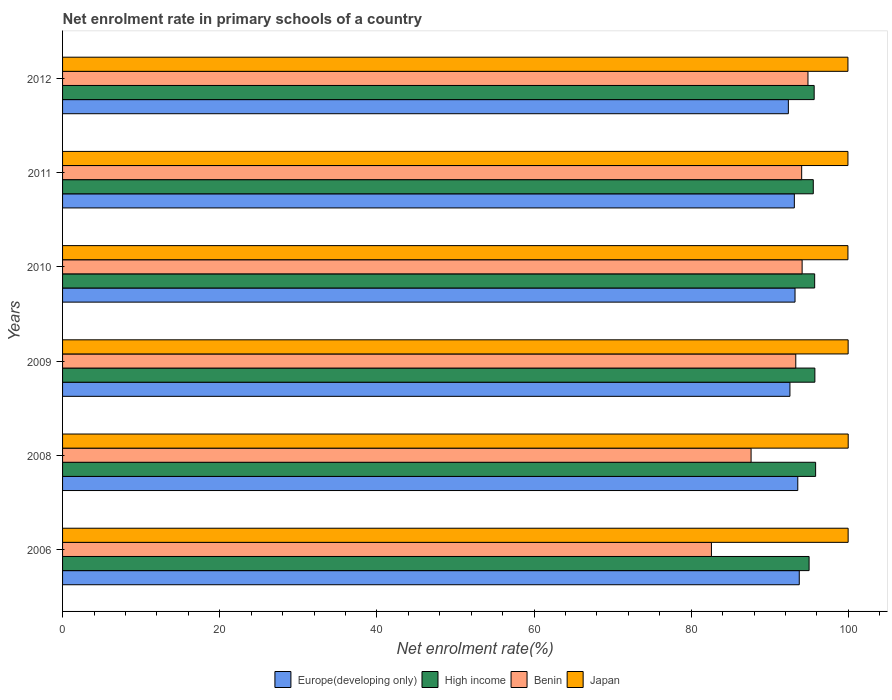How many groups of bars are there?
Your response must be concise. 6. Are the number of bars per tick equal to the number of legend labels?
Keep it short and to the point. Yes. Are the number of bars on each tick of the Y-axis equal?
Provide a short and direct response. Yes. What is the net enrolment rate in primary schools in Japan in 2011?
Keep it short and to the point. 99.95. Across all years, what is the maximum net enrolment rate in primary schools in High income?
Your answer should be compact. 95.84. Across all years, what is the minimum net enrolment rate in primary schools in Benin?
Provide a short and direct response. 82.58. What is the total net enrolment rate in primary schools in High income in the graph?
Provide a succinct answer. 573.5. What is the difference between the net enrolment rate in primary schools in Japan in 2008 and that in 2011?
Your response must be concise. 0.04. What is the difference between the net enrolment rate in primary schools in High income in 2006 and the net enrolment rate in primary schools in Japan in 2009?
Provide a short and direct response. -4.97. What is the average net enrolment rate in primary schools in Benin per year?
Give a very brief answer. 91.09. In the year 2006, what is the difference between the net enrolment rate in primary schools in Europe(developing only) and net enrolment rate in primary schools in High income?
Your answer should be compact. -1.25. In how many years, is the net enrolment rate in primary schools in Benin greater than 36 %?
Your answer should be compact. 6. What is the ratio of the net enrolment rate in primary schools in Europe(developing only) in 2008 to that in 2011?
Your answer should be very brief. 1. What is the difference between the highest and the second highest net enrolment rate in primary schools in Europe(developing only)?
Provide a succinct answer. 0.19. What is the difference between the highest and the lowest net enrolment rate in primary schools in High income?
Provide a short and direct response. 0.83. Is the sum of the net enrolment rate in primary schools in High income in 2010 and 2012 greater than the maximum net enrolment rate in primary schools in Europe(developing only) across all years?
Your answer should be very brief. Yes. Is it the case that in every year, the sum of the net enrolment rate in primary schools in Japan and net enrolment rate in primary schools in High income is greater than the sum of net enrolment rate in primary schools in Europe(developing only) and net enrolment rate in primary schools in Benin?
Your answer should be compact. Yes. What does the 2nd bar from the top in 2008 represents?
Offer a terse response. Benin. What does the 2nd bar from the bottom in 2010 represents?
Provide a short and direct response. High income. Is it the case that in every year, the sum of the net enrolment rate in primary schools in Benin and net enrolment rate in primary schools in Japan is greater than the net enrolment rate in primary schools in Europe(developing only)?
Make the answer very short. Yes. Are all the bars in the graph horizontal?
Your response must be concise. Yes. Are the values on the major ticks of X-axis written in scientific E-notation?
Give a very brief answer. No. Does the graph contain any zero values?
Make the answer very short. No. Where does the legend appear in the graph?
Make the answer very short. Bottom center. How are the legend labels stacked?
Give a very brief answer. Horizontal. What is the title of the graph?
Offer a very short reply. Net enrolment rate in primary schools of a country. Does "Latin America(developing only)" appear as one of the legend labels in the graph?
Your answer should be very brief. No. What is the label or title of the X-axis?
Offer a terse response. Net enrolment rate(%). What is the Net enrolment rate(%) in Europe(developing only) in 2006?
Keep it short and to the point. 93.76. What is the Net enrolment rate(%) of High income in 2006?
Provide a succinct answer. 95.01. What is the Net enrolment rate(%) in Benin in 2006?
Your answer should be very brief. 82.58. What is the Net enrolment rate(%) of Japan in 2006?
Offer a terse response. 99.98. What is the Net enrolment rate(%) in Europe(developing only) in 2008?
Offer a very short reply. 93.57. What is the Net enrolment rate(%) of High income in 2008?
Provide a short and direct response. 95.84. What is the Net enrolment rate(%) of Benin in 2008?
Make the answer very short. 87.62. What is the Net enrolment rate(%) in Japan in 2008?
Keep it short and to the point. 99.99. What is the Net enrolment rate(%) in Europe(developing only) in 2009?
Offer a very short reply. 92.57. What is the Net enrolment rate(%) in High income in 2009?
Your answer should be compact. 95.74. What is the Net enrolment rate(%) in Benin in 2009?
Your answer should be very brief. 93.31. What is the Net enrolment rate(%) in Japan in 2009?
Offer a terse response. 99.98. What is the Net enrolment rate(%) of Europe(developing only) in 2010?
Your answer should be very brief. 93.22. What is the Net enrolment rate(%) in High income in 2010?
Your answer should be compact. 95.72. What is the Net enrolment rate(%) in Benin in 2010?
Your response must be concise. 94.12. What is the Net enrolment rate(%) of Japan in 2010?
Offer a very short reply. 99.95. What is the Net enrolment rate(%) of Europe(developing only) in 2011?
Provide a succinct answer. 93.13. What is the Net enrolment rate(%) of High income in 2011?
Ensure brevity in your answer.  95.54. What is the Net enrolment rate(%) of Benin in 2011?
Offer a terse response. 94.06. What is the Net enrolment rate(%) of Japan in 2011?
Offer a terse response. 99.95. What is the Net enrolment rate(%) of Europe(developing only) in 2012?
Offer a terse response. 92.37. What is the Net enrolment rate(%) of High income in 2012?
Make the answer very short. 95.65. What is the Net enrolment rate(%) of Benin in 2012?
Offer a very short reply. 94.86. What is the Net enrolment rate(%) of Japan in 2012?
Provide a short and direct response. 99.95. Across all years, what is the maximum Net enrolment rate(%) in Europe(developing only)?
Ensure brevity in your answer.  93.76. Across all years, what is the maximum Net enrolment rate(%) of High income?
Your response must be concise. 95.84. Across all years, what is the maximum Net enrolment rate(%) of Benin?
Your answer should be compact. 94.86. Across all years, what is the maximum Net enrolment rate(%) of Japan?
Provide a short and direct response. 99.99. Across all years, what is the minimum Net enrolment rate(%) in Europe(developing only)?
Offer a terse response. 92.37. Across all years, what is the minimum Net enrolment rate(%) of High income?
Offer a terse response. 95.01. Across all years, what is the minimum Net enrolment rate(%) in Benin?
Provide a short and direct response. 82.58. Across all years, what is the minimum Net enrolment rate(%) in Japan?
Your answer should be very brief. 99.95. What is the total Net enrolment rate(%) in Europe(developing only) in the graph?
Offer a very short reply. 558.61. What is the total Net enrolment rate(%) of High income in the graph?
Offer a terse response. 573.5. What is the total Net enrolment rate(%) in Benin in the graph?
Give a very brief answer. 546.56. What is the total Net enrolment rate(%) of Japan in the graph?
Your response must be concise. 599.79. What is the difference between the Net enrolment rate(%) in Europe(developing only) in 2006 and that in 2008?
Your answer should be very brief. 0.19. What is the difference between the Net enrolment rate(%) in High income in 2006 and that in 2008?
Offer a very short reply. -0.83. What is the difference between the Net enrolment rate(%) of Benin in 2006 and that in 2008?
Provide a short and direct response. -5.04. What is the difference between the Net enrolment rate(%) in Japan in 2006 and that in 2008?
Make the answer very short. -0.01. What is the difference between the Net enrolment rate(%) of Europe(developing only) in 2006 and that in 2009?
Offer a terse response. 1.19. What is the difference between the Net enrolment rate(%) of High income in 2006 and that in 2009?
Ensure brevity in your answer.  -0.73. What is the difference between the Net enrolment rate(%) in Benin in 2006 and that in 2009?
Make the answer very short. -10.73. What is the difference between the Net enrolment rate(%) of Japan in 2006 and that in 2009?
Make the answer very short. -0. What is the difference between the Net enrolment rate(%) in Europe(developing only) in 2006 and that in 2010?
Ensure brevity in your answer.  0.54. What is the difference between the Net enrolment rate(%) in High income in 2006 and that in 2010?
Ensure brevity in your answer.  -0.71. What is the difference between the Net enrolment rate(%) in Benin in 2006 and that in 2010?
Ensure brevity in your answer.  -11.54. What is the difference between the Net enrolment rate(%) of Japan in 2006 and that in 2010?
Make the answer very short. 0.03. What is the difference between the Net enrolment rate(%) of Europe(developing only) in 2006 and that in 2011?
Your answer should be very brief. 0.63. What is the difference between the Net enrolment rate(%) of High income in 2006 and that in 2011?
Your answer should be very brief. -0.53. What is the difference between the Net enrolment rate(%) of Benin in 2006 and that in 2011?
Provide a short and direct response. -11.48. What is the difference between the Net enrolment rate(%) in Japan in 2006 and that in 2011?
Offer a terse response. 0.03. What is the difference between the Net enrolment rate(%) in Europe(developing only) in 2006 and that in 2012?
Your answer should be very brief. 1.39. What is the difference between the Net enrolment rate(%) of High income in 2006 and that in 2012?
Keep it short and to the point. -0.65. What is the difference between the Net enrolment rate(%) of Benin in 2006 and that in 2012?
Offer a terse response. -12.28. What is the difference between the Net enrolment rate(%) of Japan in 2006 and that in 2012?
Provide a short and direct response. 0.03. What is the difference between the Net enrolment rate(%) in High income in 2008 and that in 2009?
Your answer should be compact. 0.1. What is the difference between the Net enrolment rate(%) of Benin in 2008 and that in 2009?
Provide a succinct answer. -5.69. What is the difference between the Net enrolment rate(%) of Japan in 2008 and that in 2009?
Offer a very short reply. 0.01. What is the difference between the Net enrolment rate(%) of Europe(developing only) in 2008 and that in 2010?
Offer a very short reply. 0.35. What is the difference between the Net enrolment rate(%) of High income in 2008 and that in 2010?
Ensure brevity in your answer.  0.12. What is the difference between the Net enrolment rate(%) of Benin in 2008 and that in 2010?
Give a very brief answer. -6.5. What is the difference between the Net enrolment rate(%) of Japan in 2008 and that in 2010?
Give a very brief answer. 0.04. What is the difference between the Net enrolment rate(%) in Europe(developing only) in 2008 and that in 2011?
Provide a succinct answer. 0.44. What is the difference between the Net enrolment rate(%) of High income in 2008 and that in 2011?
Give a very brief answer. 0.3. What is the difference between the Net enrolment rate(%) of Benin in 2008 and that in 2011?
Offer a very short reply. -6.44. What is the difference between the Net enrolment rate(%) of Japan in 2008 and that in 2011?
Your response must be concise. 0.04. What is the difference between the Net enrolment rate(%) in Europe(developing only) in 2008 and that in 2012?
Make the answer very short. 1.2. What is the difference between the Net enrolment rate(%) of High income in 2008 and that in 2012?
Offer a terse response. 0.19. What is the difference between the Net enrolment rate(%) of Benin in 2008 and that in 2012?
Offer a very short reply. -7.24. What is the difference between the Net enrolment rate(%) in Japan in 2008 and that in 2012?
Your answer should be compact. 0.04. What is the difference between the Net enrolment rate(%) in Europe(developing only) in 2009 and that in 2010?
Ensure brevity in your answer.  -0.65. What is the difference between the Net enrolment rate(%) in High income in 2009 and that in 2010?
Your response must be concise. 0.03. What is the difference between the Net enrolment rate(%) in Benin in 2009 and that in 2010?
Your answer should be very brief. -0.81. What is the difference between the Net enrolment rate(%) of Japan in 2009 and that in 2010?
Provide a succinct answer. 0.03. What is the difference between the Net enrolment rate(%) of Europe(developing only) in 2009 and that in 2011?
Offer a very short reply. -0.56. What is the difference between the Net enrolment rate(%) in High income in 2009 and that in 2011?
Make the answer very short. 0.2. What is the difference between the Net enrolment rate(%) in Benin in 2009 and that in 2011?
Offer a terse response. -0.75. What is the difference between the Net enrolment rate(%) of Japan in 2009 and that in 2011?
Provide a short and direct response. 0.03. What is the difference between the Net enrolment rate(%) in Europe(developing only) in 2009 and that in 2012?
Provide a succinct answer. 0.2. What is the difference between the Net enrolment rate(%) of High income in 2009 and that in 2012?
Your response must be concise. 0.09. What is the difference between the Net enrolment rate(%) in Benin in 2009 and that in 2012?
Your response must be concise. -1.55. What is the difference between the Net enrolment rate(%) in Japan in 2009 and that in 2012?
Your answer should be compact. 0.03. What is the difference between the Net enrolment rate(%) of Europe(developing only) in 2010 and that in 2011?
Your answer should be very brief. 0.09. What is the difference between the Net enrolment rate(%) in High income in 2010 and that in 2011?
Offer a very short reply. 0.18. What is the difference between the Net enrolment rate(%) of Benin in 2010 and that in 2011?
Keep it short and to the point. 0.06. What is the difference between the Net enrolment rate(%) of Europe(developing only) in 2010 and that in 2012?
Provide a succinct answer. 0.85. What is the difference between the Net enrolment rate(%) of High income in 2010 and that in 2012?
Provide a succinct answer. 0.06. What is the difference between the Net enrolment rate(%) in Benin in 2010 and that in 2012?
Provide a succinct answer. -0.74. What is the difference between the Net enrolment rate(%) in Japan in 2010 and that in 2012?
Offer a very short reply. 0. What is the difference between the Net enrolment rate(%) of Europe(developing only) in 2011 and that in 2012?
Your answer should be compact. 0.76. What is the difference between the Net enrolment rate(%) in High income in 2011 and that in 2012?
Your answer should be compact. -0.11. What is the difference between the Net enrolment rate(%) in Benin in 2011 and that in 2012?
Provide a succinct answer. -0.8. What is the difference between the Net enrolment rate(%) in Japan in 2011 and that in 2012?
Your response must be concise. -0. What is the difference between the Net enrolment rate(%) of Europe(developing only) in 2006 and the Net enrolment rate(%) of High income in 2008?
Offer a very short reply. -2.08. What is the difference between the Net enrolment rate(%) in Europe(developing only) in 2006 and the Net enrolment rate(%) in Benin in 2008?
Your answer should be very brief. 6.13. What is the difference between the Net enrolment rate(%) in Europe(developing only) in 2006 and the Net enrolment rate(%) in Japan in 2008?
Offer a terse response. -6.23. What is the difference between the Net enrolment rate(%) of High income in 2006 and the Net enrolment rate(%) of Benin in 2008?
Ensure brevity in your answer.  7.38. What is the difference between the Net enrolment rate(%) in High income in 2006 and the Net enrolment rate(%) in Japan in 2008?
Ensure brevity in your answer.  -4.98. What is the difference between the Net enrolment rate(%) in Benin in 2006 and the Net enrolment rate(%) in Japan in 2008?
Offer a terse response. -17.41. What is the difference between the Net enrolment rate(%) in Europe(developing only) in 2006 and the Net enrolment rate(%) in High income in 2009?
Provide a succinct answer. -1.99. What is the difference between the Net enrolment rate(%) in Europe(developing only) in 2006 and the Net enrolment rate(%) in Benin in 2009?
Ensure brevity in your answer.  0.44. What is the difference between the Net enrolment rate(%) in Europe(developing only) in 2006 and the Net enrolment rate(%) in Japan in 2009?
Provide a short and direct response. -6.22. What is the difference between the Net enrolment rate(%) of High income in 2006 and the Net enrolment rate(%) of Benin in 2009?
Offer a terse response. 1.69. What is the difference between the Net enrolment rate(%) of High income in 2006 and the Net enrolment rate(%) of Japan in 2009?
Offer a terse response. -4.97. What is the difference between the Net enrolment rate(%) of Benin in 2006 and the Net enrolment rate(%) of Japan in 2009?
Keep it short and to the point. -17.4. What is the difference between the Net enrolment rate(%) in Europe(developing only) in 2006 and the Net enrolment rate(%) in High income in 2010?
Make the answer very short. -1.96. What is the difference between the Net enrolment rate(%) in Europe(developing only) in 2006 and the Net enrolment rate(%) in Benin in 2010?
Ensure brevity in your answer.  -0.36. What is the difference between the Net enrolment rate(%) in Europe(developing only) in 2006 and the Net enrolment rate(%) in Japan in 2010?
Ensure brevity in your answer.  -6.19. What is the difference between the Net enrolment rate(%) in High income in 2006 and the Net enrolment rate(%) in Benin in 2010?
Your response must be concise. 0.89. What is the difference between the Net enrolment rate(%) of High income in 2006 and the Net enrolment rate(%) of Japan in 2010?
Keep it short and to the point. -4.94. What is the difference between the Net enrolment rate(%) of Benin in 2006 and the Net enrolment rate(%) of Japan in 2010?
Keep it short and to the point. -17.37. What is the difference between the Net enrolment rate(%) in Europe(developing only) in 2006 and the Net enrolment rate(%) in High income in 2011?
Provide a succinct answer. -1.78. What is the difference between the Net enrolment rate(%) in Europe(developing only) in 2006 and the Net enrolment rate(%) in Benin in 2011?
Ensure brevity in your answer.  -0.3. What is the difference between the Net enrolment rate(%) in Europe(developing only) in 2006 and the Net enrolment rate(%) in Japan in 2011?
Provide a succinct answer. -6.19. What is the difference between the Net enrolment rate(%) of High income in 2006 and the Net enrolment rate(%) of Benin in 2011?
Provide a short and direct response. 0.95. What is the difference between the Net enrolment rate(%) of High income in 2006 and the Net enrolment rate(%) of Japan in 2011?
Your answer should be very brief. -4.94. What is the difference between the Net enrolment rate(%) in Benin in 2006 and the Net enrolment rate(%) in Japan in 2011?
Offer a terse response. -17.37. What is the difference between the Net enrolment rate(%) of Europe(developing only) in 2006 and the Net enrolment rate(%) of High income in 2012?
Give a very brief answer. -1.9. What is the difference between the Net enrolment rate(%) in Europe(developing only) in 2006 and the Net enrolment rate(%) in Benin in 2012?
Your answer should be very brief. -1.11. What is the difference between the Net enrolment rate(%) of Europe(developing only) in 2006 and the Net enrolment rate(%) of Japan in 2012?
Provide a short and direct response. -6.19. What is the difference between the Net enrolment rate(%) of High income in 2006 and the Net enrolment rate(%) of Benin in 2012?
Offer a terse response. 0.14. What is the difference between the Net enrolment rate(%) in High income in 2006 and the Net enrolment rate(%) in Japan in 2012?
Provide a succinct answer. -4.94. What is the difference between the Net enrolment rate(%) in Benin in 2006 and the Net enrolment rate(%) in Japan in 2012?
Your answer should be very brief. -17.37. What is the difference between the Net enrolment rate(%) of Europe(developing only) in 2008 and the Net enrolment rate(%) of High income in 2009?
Keep it short and to the point. -2.18. What is the difference between the Net enrolment rate(%) in Europe(developing only) in 2008 and the Net enrolment rate(%) in Benin in 2009?
Make the answer very short. 0.25. What is the difference between the Net enrolment rate(%) in Europe(developing only) in 2008 and the Net enrolment rate(%) in Japan in 2009?
Your answer should be very brief. -6.41. What is the difference between the Net enrolment rate(%) in High income in 2008 and the Net enrolment rate(%) in Benin in 2009?
Your response must be concise. 2.52. What is the difference between the Net enrolment rate(%) in High income in 2008 and the Net enrolment rate(%) in Japan in 2009?
Provide a short and direct response. -4.14. What is the difference between the Net enrolment rate(%) of Benin in 2008 and the Net enrolment rate(%) of Japan in 2009?
Offer a very short reply. -12.35. What is the difference between the Net enrolment rate(%) of Europe(developing only) in 2008 and the Net enrolment rate(%) of High income in 2010?
Keep it short and to the point. -2.15. What is the difference between the Net enrolment rate(%) in Europe(developing only) in 2008 and the Net enrolment rate(%) in Benin in 2010?
Offer a very short reply. -0.55. What is the difference between the Net enrolment rate(%) in Europe(developing only) in 2008 and the Net enrolment rate(%) in Japan in 2010?
Provide a short and direct response. -6.38. What is the difference between the Net enrolment rate(%) of High income in 2008 and the Net enrolment rate(%) of Benin in 2010?
Your answer should be very brief. 1.72. What is the difference between the Net enrolment rate(%) of High income in 2008 and the Net enrolment rate(%) of Japan in 2010?
Ensure brevity in your answer.  -4.11. What is the difference between the Net enrolment rate(%) of Benin in 2008 and the Net enrolment rate(%) of Japan in 2010?
Your answer should be very brief. -12.33. What is the difference between the Net enrolment rate(%) in Europe(developing only) in 2008 and the Net enrolment rate(%) in High income in 2011?
Ensure brevity in your answer.  -1.97. What is the difference between the Net enrolment rate(%) in Europe(developing only) in 2008 and the Net enrolment rate(%) in Benin in 2011?
Offer a very short reply. -0.49. What is the difference between the Net enrolment rate(%) in Europe(developing only) in 2008 and the Net enrolment rate(%) in Japan in 2011?
Make the answer very short. -6.38. What is the difference between the Net enrolment rate(%) in High income in 2008 and the Net enrolment rate(%) in Benin in 2011?
Your response must be concise. 1.78. What is the difference between the Net enrolment rate(%) in High income in 2008 and the Net enrolment rate(%) in Japan in 2011?
Ensure brevity in your answer.  -4.11. What is the difference between the Net enrolment rate(%) in Benin in 2008 and the Net enrolment rate(%) in Japan in 2011?
Ensure brevity in your answer.  -12.33. What is the difference between the Net enrolment rate(%) of Europe(developing only) in 2008 and the Net enrolment rate(%) of High income in 2012?
Ensure brevity in your answer.  -2.09. What is the difference between the Net enrolment rate(%) of Europe(developing only) in 2008 and the Net enrolment rate(%) of Benin in 2012?
Offer a very short reply. -1.3. What is the difference between the Net enrolment rate(%) in Europe(developing only) in 2008 and the Net enrolment rate(%) in Japan in 2012?
Ensure brevity in your answer.  -6.38. What is the difference between the Net enrolment rate(%) in High income in 2008 and the Net enrolment rate(%) in Benin in 2012?
Provide a succinct answer. 0.97. What is the difference between the Net enrolment rate(%) in High income in 2008 and the Net enrolment rate(%) in Japan in 2012?
Your answer should be very brief. -4.11. What is the difference between the Net enrolment rate(%) in Benin in 2008 and the Net enrolment rate(%) in Japan in 2012?
Give a very brief answer. -12.33. What is the difference between the Net enrolment rate(%) in Europe(developing only) in 2009 and the Net enrolment rate(%) in High income in 2010?
Offer a terse response. -3.15. What is the difference between the Net enrolment rate(%) of Europe(developing only) in 2009 and the Net enrolment rate(%) of Benin in 2010?
Your answer should be compact. -1.55. What is the difference between the Net enrolment rate(%) of Europe(developing only) in 2009 and the Net enrolment rate(%) of Japan in 2010?
Your response must be concise. -7.38. What is the difference between the Net enrolment rate(%) of High income in 2009 and the Net enrolment rate(%) of Benin in 2010?
Keep it short and to the point. 1.62. What is the difference between the Net enrolment rate(%) in High income in 2009 and the Net enrolment rate(%) in Japan in 2010?
Your answer should be compact. -4.21. What is the difference between the Net enrolment rate(%) in Benin in 2009 and the Net enrolment rate(%) in Japan in 2010?
Offer a terse response. -6.64. What is the difference between the Net enrolment rate(%) of Europe(developing only) in 2009 and the Net enrolment rate(%) of High income in 2011?
Your answer should be compact. -2.97. What is the difference between the Net enrolment rate(%) of Europe(developing only) in 2009 and the Net enrolment rate(%) of Benin in 2011?
Keep it short and to the point. -1.49. What is the difference between the Net enrolment rate(%) in Europe(developing only) in 2009 and the Net enrolment rate(%) in Japan in 2011?
Offer a terse response. -7.38. What is the difference between the Net enrolment rate(%) of High income in 2009 and the Net enrolment rate(%) of Benin in 2011?
Make the answer very short. 1.68. What is the difference between the Net enrolment rate(%) of High income in 2009 and the Net enrolment rate(%) of Japan in 2011?
Keep it short and to the point. -4.21. What is the difference between the Net enrolment rate(%) in Benin in 2009 and the Net enrolment rate(%) in Japan in 2011?
Make the answer very short. -6.64. What is the difference between the Net enrolment rate(%) in Europe(developing only) in 2009 and the Net enrolment rate(%) in High income in 2012?
Your response must be concise. -3.08. What is the difference between the Net enrolment rate(%) in Europe(developing only) in 2009 and the Net enrolment rate(%) in Benin in 2012?
Make the answer very short. -2.29. What is the difference between the Net enrolment rate(%) in Europe(developing only) in 2009 and the Net enrolment rate(%) in Japan in 2012?
Offer a very short reply. -7.38. What is the difference between the Net enrolment rate(%) in High income in 2009 and the Net enrolment rate(%) in Benin in 2012?
Provide a succinct answer. 0.88. What is the difference between the Net enrolment rate(%) of High income in 2009 and the Net enrolment rate(%) of Japan in 2012?
Offer a terse response. -4.21. What is the difference between the Net enrolment rate(%) in Benin in 2009 and the Net enrolment rate(%) in Japan in 2012?
Provide a short and direct response. -6.64. What is the difference between the Net enrolment rate(%) of Europe(developing only) in 2010 and the Net enrolment rate(%) of High income in 2011?
Provide a succinct answer. -2.32. What is the difference between the Net enrolment rate(%) of Europe(developing only) in 2010 and the Net enrolment rate(%) of Benin in 2011?
Offer a terse response. -0.84. What is the difference between the Net enrolment rate(%) in Europe(developing only) in 2010 and the Net enrolment rate(%) in Japan in 2011?
Give a very brief answer. -6.73. What is the difference between the Net enrolment rate(%) of High income in 2010 and the Net enrolment rate(%) of Benin in 2011?
Your answer should be compact. 1.65. What is the difference between the Net enrolment rate(%) of High income in 2010 and the Net enrolment rate(%) of Japan in 2011?
Your answer should be very brief. -4.23. What is the difference between the Net enrolment rate(%) of Benin in 2010 and the Net enrolment rate(%) of Japan in 2011?
Make the answer very short. -5.83. What is the difference between the Net enrolment rate(%) of Europe(developing only) in 2010 and the Net enrolment rate(%) of High income in 2012?
Make the answer very short. -2.44. What is the difference between the Net enrolment rate(%) in Europe(developing only) in 2010 and the Net enrolment rate(%) in Benin in 2012?
Your answer should be compact. -1.65. What is the difference between the Net enrolment rate(%) in Europe(developing only) in 2010 and the Net enrolment rate(%) in Japan in 2012?
Your answer should be compact. -6.73. What is the difference between the Net enrolment rate(%) in High income in 2010 and the Net enrolment rate(%) in Benin in 2012?
Give a very brief answer. 0.85. What is the difference between the Net enrolment rate(%) in High income in 2010 and the Net enrolment rate(%) in Japan in 2012?
Your response must be concise. -4.23. What is the difference between the Net enrolment rate(%) in Benin in 2010 and the Net enrolment rate(%) in Japan in 2012?
Offer a very short reply. -5.83. What is the difference between the Net enrolment rate(%) in Europe(developing only) in 2011 and the Net enrolment rate(%) in High income in 2012?
Provide a short and direct response. -2.52. What is the difference between the Net enrolment rate(%) in Europe(developing only) in 2011 and the Net enrolment rate(%) in Benin in 2012?
Give a very brief answer. -1.73. What is the difference between the Net enrolment rate(%) in Europe(developing only) in 2011 and the Net enrolment rate(%) in Japan in 2012?
Offer a terse response. -6.82. What is the difference between the Net enrolment rate(%) of High income in 2011 and the Net enrolment rate(%) of Benin in 2012?
Provide a short and direct response. 0.68. What is the difference between the Net enrolment rate(%) in High income in 2011 and the Net enrolment rate(%) in Japan in 2012?
Keep it short and to the point. -4.41. What is the difference between the Net enrolment rate(%) in Benin in 2011 and the Net enrolment rate(%) in Japan in 2012?
Your answer should be very brief. -5.89. What is the average Net enrolment rate(%) in Europe(developing only) per year?
Provide a succinct answer. 93.1. What is the average Net enrolment rate(%) of High income per year?
Your answer should be very brief. 95.58. What is the average Net enrolment rate(%) of Benin per year?
Provide a short and direct response. 91.09. What is the average Net enrolment rate(%) of Japan per year?
Offer a very short reply. 99.96. In the year 2006, what is the difference between the Net enrolment rate(%) of Europe(developing only) and Net enrolment rate(%) of High income?
Offer a terse response. -1.25. In the year 2006, what is the difference between the Net enrolment rate(%) of Europe(developing only) and Net enrolment rate(%) of Benin?
Offer a very short reply. 11.18. In the year 2006, what is the difference between the Net enrolment rate(%) of Europe(developing only) and Net enrolment rate(%) of Japan?
Keep it short and to the point. -6.22. In the year 2006, what is the difference between the Net enrolment rate(%) of High income and Net enrolment rate(%) of Benin?
Provide a succinct answer. 12.43. In the year 2006, what is the difference between the Net enrolment rate(%) of High income and Net enrolment rate(%) of Japan?
Offer a very short reply. -4.97. In the year 2006, what is the difference between the Net enrolment rate(%) of Benin and Net enrolment rate(%) of Japan?
Give a very brief answer. -17.4. In the year 2008, what is the difference between the Net enrolment rate(%) in Europe(developing only) and Net enrolment rate(%) in High income?
Provide a succinct answer. -2.27. In the year 2008, what is the difference between the Net enrolment rate(%) in Europe(developing only) and Net enrolment rate(%) in Benin?
Provide a short and direct response. 5.94. In the year 2008, what is the difference between the Net enrolment rate(%) in Europe(developing only) and Net enrolment rate(%) in Japan?
Give a very brief answer. -6.42. In the year 2008, what is the difference between the Net enrolment rate(%) in High income and Net enrolment rate(%) in Benin?
Give a very brief answer. 8.21. In the year 2008, what is the difference between the Net enrolment rate(%) in High income and Net enrolment rate(%) in Japan?
Your answer should be very brief. -4.15. In the year 2008, what is the difference between the Net enrolment rate(%) of Benin and Net enrolment rate(%) of Japan?
Your response must be concise. -12.36. In the year 2009, what is the difference between the Net enrolment rate(%) in Europe(developing only) and Net enrolment rate(%) in High income?
Provide a succinct answer. -3.17. In the year 2009, what is the difference between the Net enrolment rate(%) of Europe(developing only) and Net enrolment rate(%) of Benin?
Offer a very short reply. -0.74. In the year 2009, what is the difference between the Net enrolment rate(%) in Europe(developing only) and Net enrolment rate(%) in Japan?
Keep it short and to the point. -7.41. In the year 2009, what is the difference between the Net enrolment rate(%) in High income and Net enrolment rate(%) in Benin?
Provide a short and direct response. 2.43. In the year 2009, what is the difference between the Net enrolment rate(%) in High income and Net enrolment rate(%) in Japan?
Keep it short and to the point. -4.23. In the year 2009, what is the difference between the Net enrolment rate(%) of Benin and Net enrolment rate(%) of Japan?
Offer a terse response. -6.66. In the year 2010, what is the difference between the Net enrolment rate(%) of Europe(developing only) and Net enrolment rate(%) of High income?
Give a very brief answer. -2.5. In the year 2010, what is the difference between the Net enrolment rate(%) in Europe(developing only) and Net enrolment rate(%) in Benin?
Make the answer very short. -0.9. In the year 2010, what is the difference between the Net enrolment rate(%) of Europe(developing only) and Net enrolment rate(%) of Japan?
Your answer should be compact. -6.73. In the year 2010, what is the difference between the Net enrolment rate(%) of High income and Net enrolment rate(%) of Benin?
Provide a succinct answer. 1.6. In the year 2010, what is the difference between the Net enrolment rate(%) in High income and Net enrolment rate(%) in Japan?
Your response must be concise. -4.23. In the year 2010, what is the difference between the Net enrolment rate(%) in Benin and Net enrolment rate(%) in Japan?
Provide a short and direct response. -5.83. In the year 2011, what is the difference between the Net enrolment rate(%) of Europe(developing only) and Net enrolment rate(%) of High income?
Make the answer very short. -2.41. In the year 2011, what is the difference between the Net enrolment rate(%) of Europe(developing only) and Net enrolment rate(%) of Benin?
Provide a short and direct response. -0.93. In the year 2011, what is the difference between the Net enrolment rate(%) in Europe(developing only) and Net enrolment rate(%) in Japan?
Provide a short and direct response. -6.82. In the year 2011, what is the difference between the Net enrolment rate(%) in High income and Net enrolment rate(%) in Benin?
Offer a very short reply. 1.48. In the year 2011, what is the difference between the Net enrolment rate(%) of High income and Net enrolment rate(%) of Japan?
Provide a succinct answer. -4.41. In the year 2011, what is the difference between the Net enrolment rate(%) in Benin and Net enrolment rate(%) in Japan?
Your answer should be very brief. -5.89. In the year 2012, what is the difference between the Net enrolment rate(%) of Europe(developing only) and Net enrolment rate(%) of High income?
Your answer should be very brief. -3.29. In the year 2012, what is the difference between the Net enrolment rate(%) of Europe(developing only) and Net enrolment rate(%) of Benin?
Your response must be concise. -2.5. In the year 2012, what is the difference between the Net enrolment rate(%) in Europe(developing only) and Net enrolment rate(%) in Japan?
Offer a terse response. -7.58. In the year 2012, what is the difference between the Net enrolment rate(%) in High income and Net enrolment rate(%) in Benin?
Give a very brief answer. 0.79. In the year 2012, what is the difference between the Net enrolment rate(%) in High income and Net enrolment rate(%) in Japan?
Ensure brevity in your answer.  -4.3. In the year 2012, what is the difference between the Net enrolment rate(%) in Benin and Net enrolment rate(%) in Japan?
Your response must be concise. -5.09. What is the ratio of the Net enrolment rate(%) of Europe(developing only) in 2006 to that in 2008?
Give a very brief answer. 1. What is the ratio of the Net enrolment rate(%) in High income in 2006 to that in 2008?
Your answer should be very brief. 0.99. What is the ratio of the Net enrolment rate(%) of Benin in 2006 to that in 2008?
Make the answer very short. 0.94. What is the ratio of the Net enrolment rate(%) of Japan in 2006 to that in 2008?
Offer a terse response. 1. What is the ratio of the Net enrolment rate(%) of Europe(developing only) in 2006 to that in 2009?
Offer a terse response. 1.01. What is the ratio of the Net enrolment rate(%) in Benin in 2006 to that in 2009?
Your answer should be very brief. 0.89. What is the ratio of the Net enrolment rate(%) of Japan in 2006 to that in 2009?
Offer a very short reply. 1. What is the ratio of the Net enrolment rate(%) of Benin in 2006 to that in 2010?
Give a very brief answer. 0.88. What is the ratio of the Net enrolment rate(%) of High income in 2006 to that in 2011?
Offer a very short reply. 0.99. What is the ratio of the Net enrolment rate(%) of Benin in 2006 to that in 2011?
Offer a terse response. 0.88. What is the ratio of the Net enrolment rate(%) in Japan in 2006 to that in 2011?
Your response must be concise. 1. What is the ratio of the Net enrolment rate(%) in Europe(developing only) in 2006 to that in 2012?
Your response must be concise. 1.01. What is the ratio of the Net enrolment rate(%) in Benin in 2006 to that in 2012?
Your answer should be compact. 0.87. What is the ratio of the Net enrolment rate(%) of Japan in 2006 to that in 2012?
Provide a succinct answer. 1. What is the ratio of the Net enrolment rate(%) of Europe(developing only) in 2008 to that in 2009?
Ensure brevity in your answer.  1.01. What is the ratio of the Net enrolment rate(%) of High income in 2008 to that in 2009?
Your answer should be compact. 1. What is the ratio of the Net enrolment rate(%) of Benin in 2008 to that in 2009?
Your response must be concise. 0.94. What is the ratio of the Net enrolment rate(%) in High income in 2008 to that in 2010?
Offer a very short reply. 1. What is the ratio of the Net enrolment rate(%) of Benin in 2008 to that in 2011?
Provide a succinct answer. 0.93. What is the ratio of the Net enrolment rate(%) of Japan in 2008 to that in 2011?
Provide a succinct answer. 1. What is the ratio of the Net enrolment rate(%) in Europe(developing only) in 2008 to that in 2012?
Provide a short and direct response. 1.01. What is the ratio of the Net enrolment rate(%) in High income in 2008 to that in 2012?
Ensure brevity in your answer.  1. What is the ratio of the Net enrolment rate(%) of Benin in 2008 to that in 2012?
Offer a terse response. 0.92. What is the ratio of the Net enrolment rate(%) in Europe(developing only) in 2009 to that in 2010?
Provide a succinct answer. 0.99. What is the ratio of the Net enrolment rate(%) of Benin in 2009 to that in 2010?
Make the answer very short. 0.99. What is the ratio of the Net enrolment rate(%) in Japan in 2009 to that in 2011?
Offer a terse response. 1. What is the ratio of the Net enrolment rate(%) in Benin in 2009 to that in 2012?
Give a very brief answer. 0.98. What is the ratio of the Net enrolment rate(%) in High income in 2010 to that in 2011?
Give a very brief answer. 1. What is the ratio of the Net enrolment rate(%) in Benin in 2010 to that in 2011?
Keep it short and to the point. 1. What is the ratio of the Net enrolment rate(%) in Europe(developing only) in 2010 to that in 2012?
Offer a very short reply. 1.01. What is the ratio of the Net enrolment rate(%) in High income in 2010 to that in 2012?
Keep it short and to the point. 1. What is the ratio of the Net enrolment rate(%) in Benin in 2010 to that in 2012?
Your answer should be compact. 0.99. What is the ratio of the Net enrolment rate(%) in Europe(developing only) in 2011 to that in 2012?
Your answer should be compact. 1.01. What is the difference between the highest and the second highest Net enrolment rate(%) in Europe(developing only)?
Your answer should be compact. 0.19. What is the difference between the highest and the second highest Net enrolment rate(%) of High income?
Ensure brevity in your answer.  0.1. What is the difference between the highest and the second highest Net enrolment rate(%) in Benin?
Offer a terse response. 0.74. What is the difference between the highest and the second highest Net enrolment rate(%) in Japan?
Provide a short and direct response. 0.01. What is the difference between the highest and the lowest Net enrolment rate(%) of Europe(developing only)?
Provide a succinct answer. 1.39. What is the difference between the highest and the lowest Net enrolment rate(%) in High income?
Your answer should be compact. 0.83. What is the difference between the highest and the lowest Net enrolment rate(%) of Benin?
Your answer should be very brief. 12.28. What is the difference between the highest and the lowest Net enrolment rate(%) in Japan?
Your answer should be compact. 0.04. 